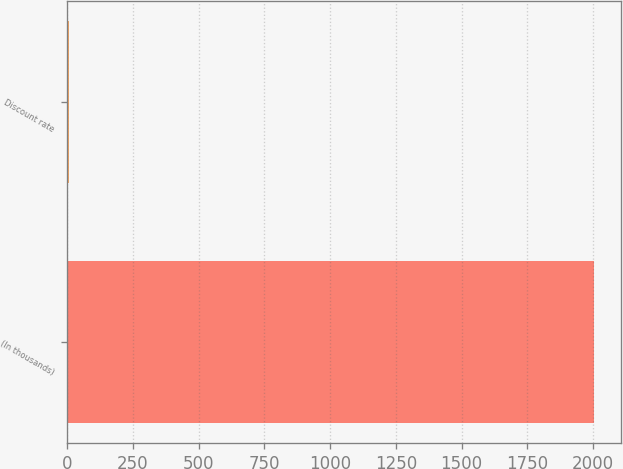Convert chart to OTSL. <chart><loc_0><loc_0><loc_500><loc_500><bar_chart><fcel>(In thousands)<fcel>Discount rate<nl><fcel>2005<fcel>5.5<nl></chart> 